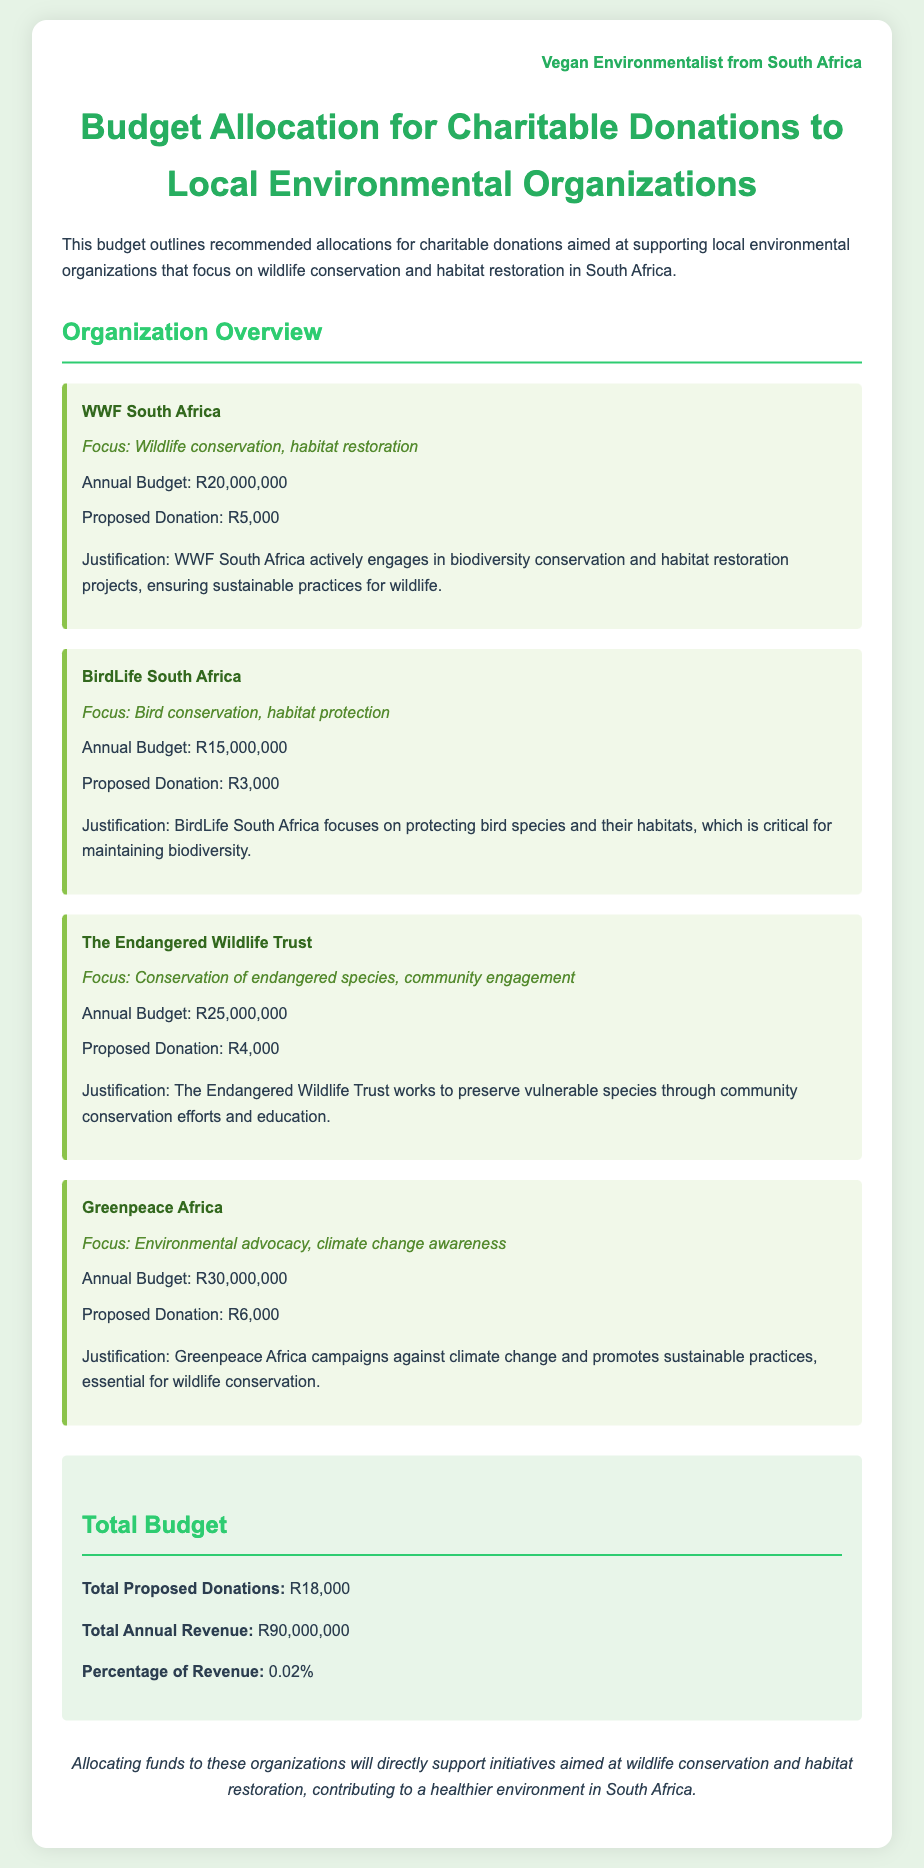What is the focus of WWF South Africa? The focus of WWF South Africa, as mentioned in the document, is "Wildlife conservation, habitat restoration."
Answer: Wildlife conservation, habitat restoration What is the proposed donation for BirdLife South Africa? The proposed donation for BirdLife South Africa is stated directly in the document as R3,000.
Answer: R3,000 How much is the annual budget of Greenpeace Africa? The document lists the annual budget of Greenpeace Africa as R30,000,000.
Answer: R30,000,000 What percentage of total annual revenue does the proposed donations represent? The document calculates the percentage of revenue represented by the proposed donations as 0.02%.
Answer: 0.02% What is the total proposed donations amount? The document summarizes the total proposed donations as R18,000.
Answer: R18,000 Which organization focuses on the conservation of endangered species? The document specifies that "The Endangered Wildlife Trust" focuses on conservation of endangered species.
Answer: The Endangered Wildlife Trust What is the justification for the donation to Greenpeace Africa? The document provides the justification as "Greenpeace Africa campaigns against climate change and promotes sustainable practices."
Answer: Greenpeace Africa campaigns against climate change and promotes sustainable practices What is the total annual revenue mentioned in the budget? The total annual revenue mentioned in the budget is R90,000,000.
Answer: R90,000,000 Which organization is allocated the highest proposed donation? The organization with the highest proposed donation is "Greenpeace Africa" with R6,000.
Answer: Greenpeace Africa 